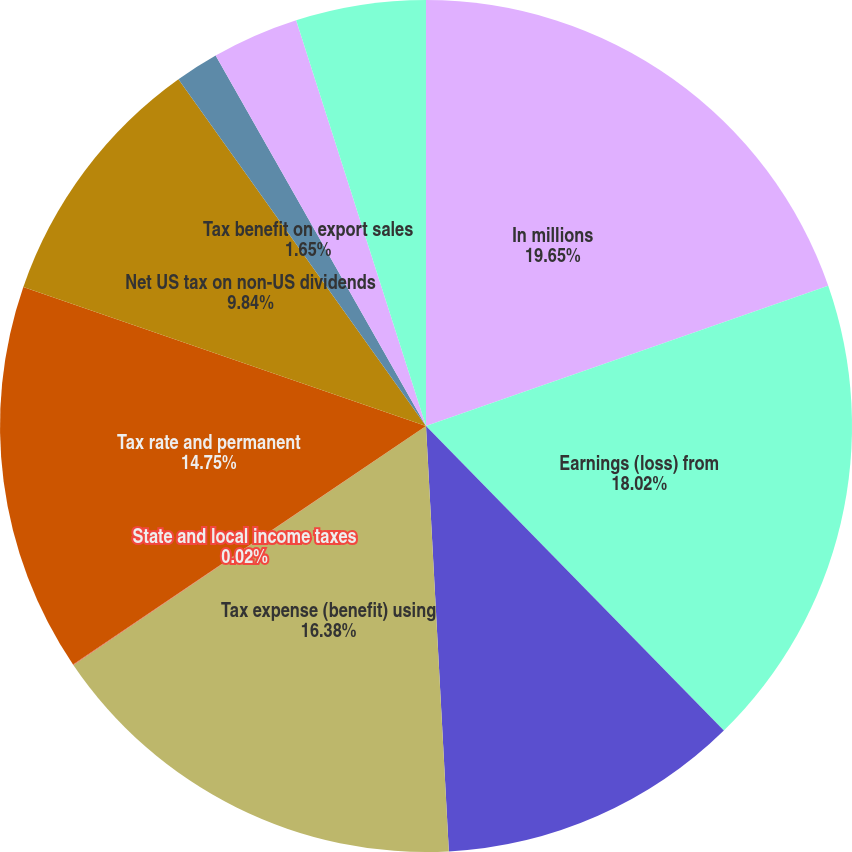Convert chart to OTSL. <chart><loc_0><loc_0><loc_500><loc_500><pie_chart><fcel>In millions<fcel>Earnings (loss) from<fcel>Statutory US income tax rate<fcel>Tax expense (benefit) using<fcel>State and local income taxes<fcel>Tax rate and permanent<fcel>Net US tax on non-US dividends<fcel>Tax benefit on export sales<fcel>Non-deductible business<fcel>Retirement plan dividends<nl><fcel>19.66%<fcel>18.02%<fcel>11.47%<fcel>16.38%<fcel>0.02%<fcel>14.75%<fcel>9.84%<fcel>1.65%<fcel>3.29%<fcel>4.93%<nl></chart> 